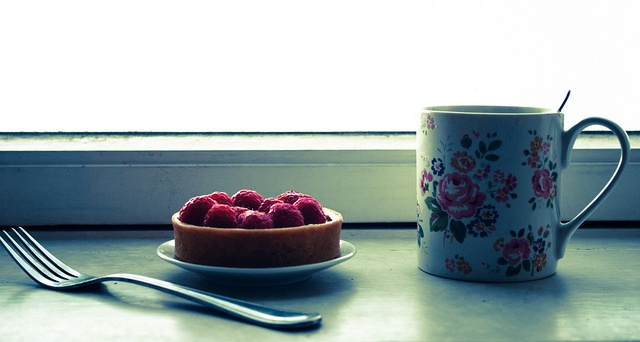Describe the objects in this image and their specific colors. I can see cup in white, darkblue, black, blue, and teal tones, cake in white, black, maroon, purple, and brown tones, bowl in white, black, maroon, brown, and gray tones, fork in white, ivory, navy, blue, and black tones, and bowl in white, black, blue, darkblue, and darkgray tones in this image. 